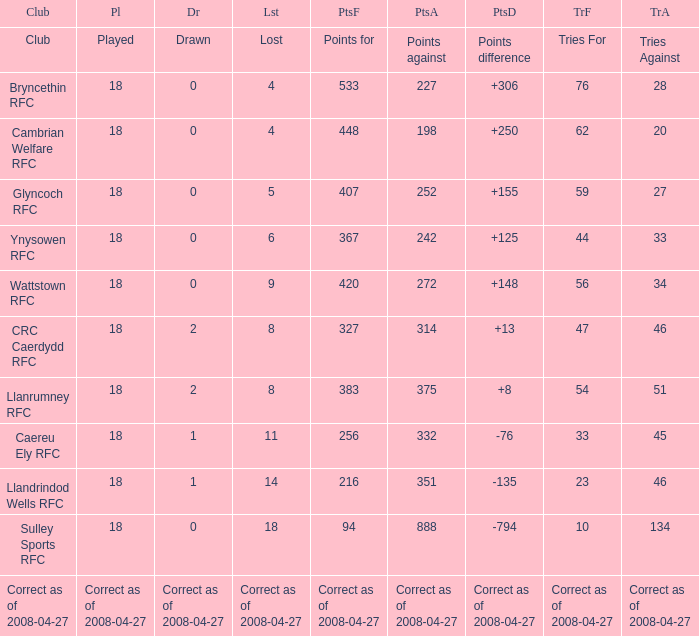What is the value for the item "Tries" when the value of the item "Played" is 18 and the value of the item "Points" is 375? 54.0. 